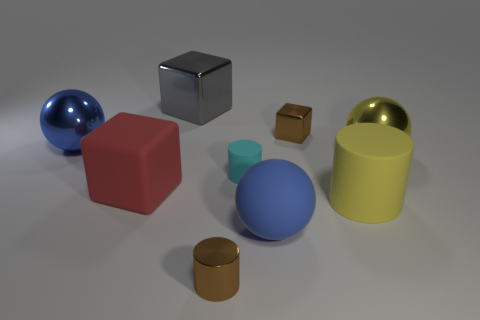What shape is the big metal thing that is to the right of the big gray metal cube?
Provide a short and direct response. Sphere. The object that is the same color as the large rubber sphere is what size?
Offer a very short reply. Large. Is there a red cube of the same size as the gray object?
Your answer should be compact. Yes. Is the material of the large blue ball that is to the right of the cyan matte cylinder the same as the small cyan thing?
Your answer should be very brief. Yes. Are there an equal number of small matte cylinders that are behind the cyan object and brown cylinders that are on the left side of the large red cube?
Offer a very short reply. Yes. What is the shape of the thing that is in front of the tiny cyan cylinder and to the right of the big matte sphere?
Offer a terse response. Cylinder. How many brown things are to the right of the cyan cylinder?
Your response must be concise. 1. How many other objects are the same shape as the yellow rubber thing?
Ensure brevity in your answer.  2. Are there fewer small green spheres than blue rubber objects?
Make the answer very short. Yes. How big is the ball that is right of the brown cylinder and to the left of the large yellow matte thing?
Your answer should be compact. Large. 